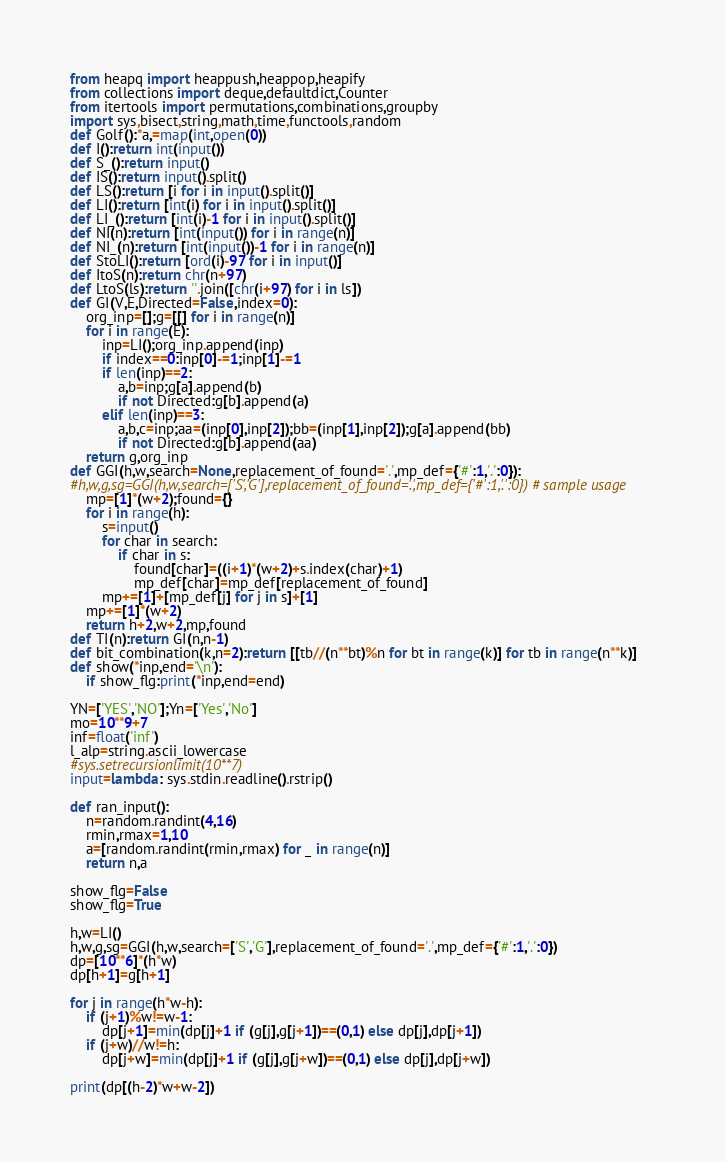<code> <loc_0><loc_0><loc_500><loc_500><_Python_>from heapq import heappush,heappop,heapify
from collections import deque,defaultdict,Counter
from itertools import permutations,combinations,groupby
import sys,bisect,string,math,time,functools,random
def Golf():*a,=map(int,open(0))
def I():return int(input())
def S_():return input()
def IS():return input().split()
def LS():return [i for i in input().split()]
def LI():return [int(i) for i in input().split()]
def LI_():return [int(i)-1 for i in input().split()]
def NI(n):return [int(input()) for i in range(n)]
def NI_(n):return [int(input())-1 for i in range(n)]
def StoLI():return [ord(i)-97 for i in input()]
def ItoS(n):return chr(n+97)
def LtoS(ls):return ''.join([chr(i+97) for i in ls])
def GI(V,E,Directed=False,index=0):
    org_inp=[];g=[[] for i in range(n)]
    for i in range(E):
        inp=LI();org_inp.append(inp)
        if index==0:inp[0]-=1;inp[1]-=1
        if len(inp)==2:
            a,b=inp;g[a].append(b)
            if not Directed:g[b].append(a)
        elif len(inp)==3:
            a,b,c=inp;aa=(inp[0],inp[2]);bb=(inp[1],inp[2]);g[a].append(bb)
            if not Directed:g[b].append(aa)
    return g,org_inp
def GGI(h,w,search=None,replacement_of_found='.',mp_def={'#':1,'.':0}):
#h,w,g,sg=GGI(h,w,search=['S','G'],replacement_of_found='.',mp_def={'#':1,'.':0}) # sample usage
    mp=[1]*(w+2);found={}
    for i in range(h):
        s=input()
        for char in search:
            if char in s:
                found[char]=((i+1)*(w+2)+s.index(char)+1)
                mp_def[char]=mp_def[replacement_of_found]
        mp+=[1]+[mp_def[j] for j in s]+[1]
    mp+=[1]*(w+2)
    return h+2,w+2,mp,found
def TI(n):return GI(n,n-1)
def bit_combination(k,n=2):return [[tb//(n**bt)%n for bt in range(k)] for tb in range(n**k)]
def show(*inp,end='\n'):
    if show_flg:print(*inp,end=end)

YN=['YES','NO'];Yn=['Yes','No']
mo=10**9+7
inf=float('inf')
l_alp=string.ascii_lowercase
#sys.setrecursionlimit(10**7)
input=lambda: sys.stdin.readline().rstrip()

def ran_input():
    n=random.randint(4,16)
    rmin,rmax=1,10
    a=[random.randint(rmin,rmax) for _ in range(n)]
    return n,a

show_flg=False
show_flg=True

h,w=LI()
h,w,g,sg=GGI(h,w,search=['S','G'],replacement_of_found='.',mp_def={'#':1,'.':0})
dp=[10**6]*(h*w)
dp[h+1]=g[h+1]

for j in range(h*w-h):
    if (j+1)%w!=w-1:
        dp[j+1]=min(dp[j]+1 if (g[j],g[j+1])==(0,1) else dp[j],dp[j+1])
    if (j+w)//w!=h:
        dp[j+w]=min(dp[j]+1 if (g[j],g[j+w])==(0,1) else dp[j],dp[j+w])

print(dp[(h-2)*w+w-2])</code> 